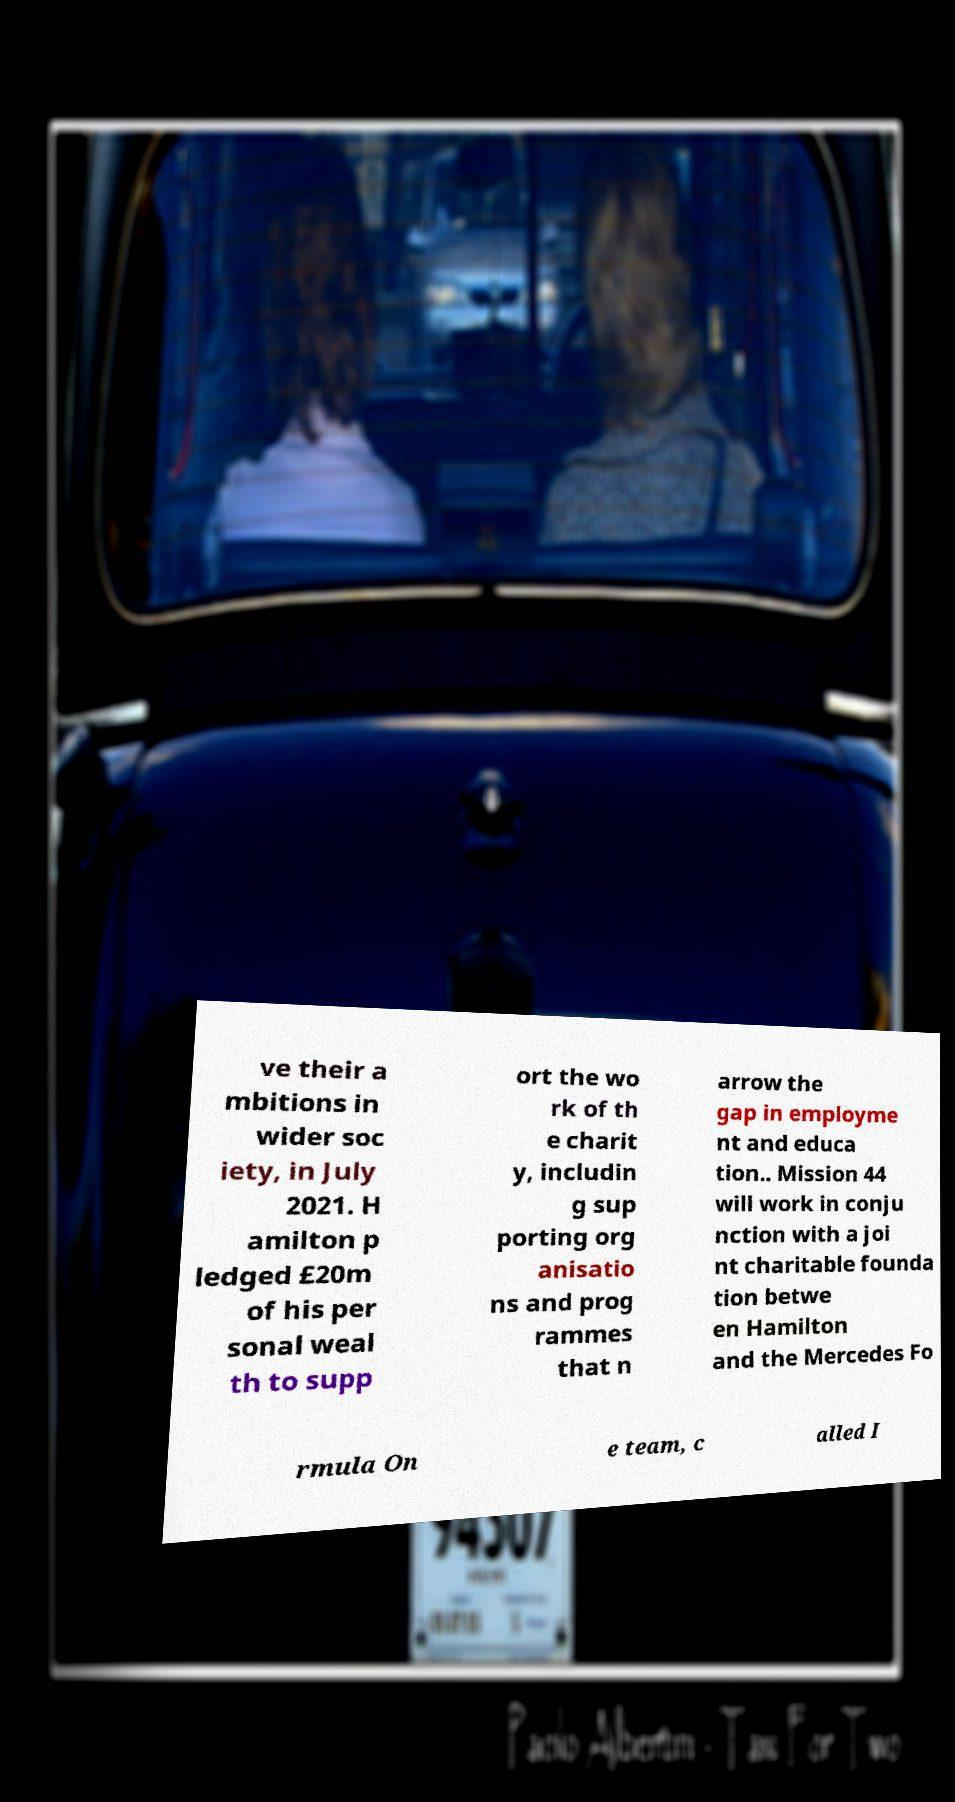Please read and relay the text visible in this image. What does it say? ve their a mbitions in wider soc iety, in July 2021. H amilton p ledged £20m of his per sonal weal th to supp ort the wo rk of th e charit y, includin g sup porting org anisatio ns and prog rammes that n arrow the gap in employme nt and educa tion.. Mission 44 will work in conju nction with a joi nt charitable founda tion betwe en Hamilton and the Mercedes Fo rmula On e team, c alled I 